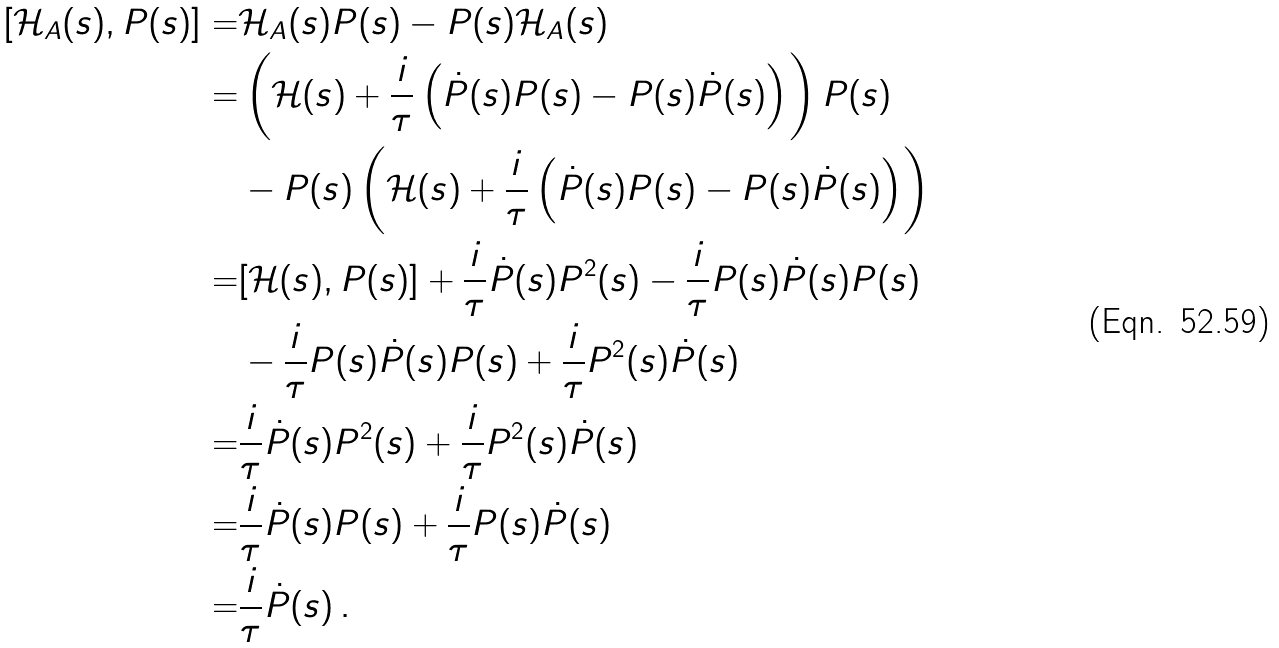Convert formula to latex. <formula><loc_0><loc_0><loc_500><loc_500>[ \mathcal { H } _ { A } ( s ) , P ( s ) ] = & \mathcal { H } _ { A } ( s ) P ( s ) - P ( s ) \mathcal { H } _ { A } ( s ) \\ = & \left ( \mathcal { H } ( s ) + \frac { i } { \tau } \left ( \dot { P } ( s ) P ( s ) - P ( s ) \dot { P } ( s ) \right ) \right ) P ( s ) \\ & - P ( s ) \left ( \mathcal { H } ( s ) + \frac { i } { \tau } \left ( \dot { P } ( s ) P ( s ) - P ( s ) \dot { P } ( s ) \right ) \right ) \\ = & [ \mathcal { H } ( s ) , P ( s ) ] + \frac { i } { \tau } \dot { P } ( s ) P ^ { 2 } ( s ) - \frac { i } { \tau } P ( s ) \dot { P } ( s ) P ( s ) \\ & - \frac { i } { \tau } P ( s ) \dot { P } ( s ) P ( s ) + \frac { i } { \tau } P ^ { 2 } ( s ) \dot { P } ( s ) \\ = & \frac { i } { \tau } \dot { P } ( s ) P ^ { 2 } ( s ) + \frac { i } { \tau } P ^ { 2 } ( s ) \dot { P } ( s ) \\ = & \frac { i } { \tau } \dot { P } ( s ) P ( s ) + \frac { i } { \tau } P ( s ) \dot { P } ( s ) \\ = & \frac { i } { \tau } \dot { P } ( s ) \, .</formula> 